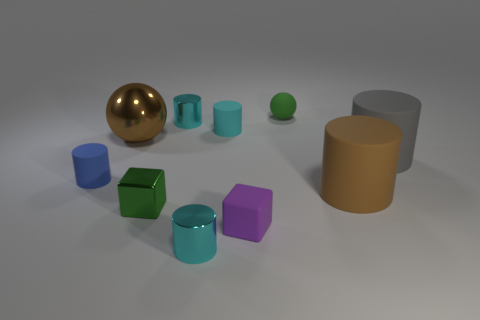There is a metallic cube; is it the same color as the large object that is to the left of the small green rubber thing?
Keep it short and to the point. No. What number of cylinders are there?
Keep it short and to the point. 6. How many things are either green matte blocks or cyan metallic objects?
Provide a succinct answer. 2. There is a matte thing that is the same color as the metal ball; what is its size?
Make the answer very short. Large. There is a blue rubber thing; are there any cyan objects behind it?
Ensure brevity in your answer.  Yes. Are there more tiny purple matte cubes in front of the green matte ball than green cubes that are to the right of the small cyan rubber object?
Your answer should be very brief. Yes. There is a cyan rubber thing that is the same shape as the big gray object; what is its size?
Ensure brevity in your answer.  Small. What number of blocks are cyan things or rubber things?
Provide a short and direct response. 1. There is a small cube that is the same color as the small ball; what is its material?
Offer a terse response. Metal. Are there fewer brown cylinders that are behind the gray thing than large gray things that are left of the tiny cyan matte thing?
Make the answer very short. No. 